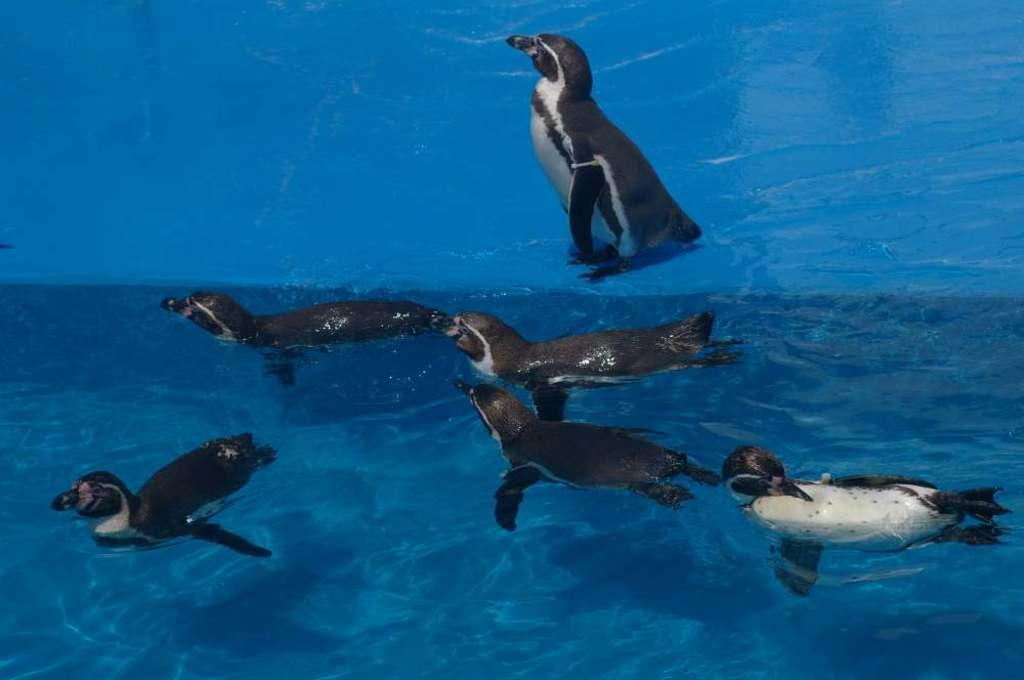How many penguins are in the image? There are six penguins in the image. Where are the penguins located in the image? The penguins are in the water. What type of rake is being used by the penguins in the image? There is no rake present in the image; the penguins are in the water. 